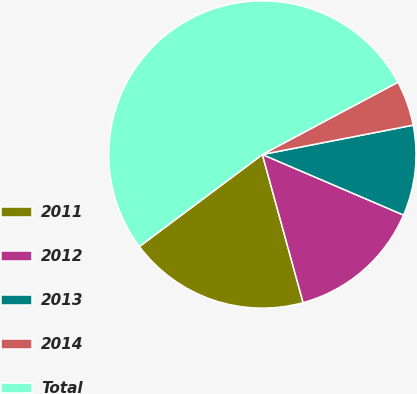<chart> <loc_0><loc_0><loc_500><loc_500><pie_chart><fcel>2011<fcel>2012<fcel>2013<fcel>2014<fcel>Total<nl><fcel>19.05%<fcel>14.28%<fcel>9.51%<fcel>4.74%<fcel>52.43%<nl></chart> 